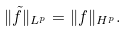<formula> <loc_0><loc_0><loc_500><loc_500>\| { \tilde { f } } \| _ { L ^ { p } } = \| f \| _ { H ^ { p } } .</formula> 